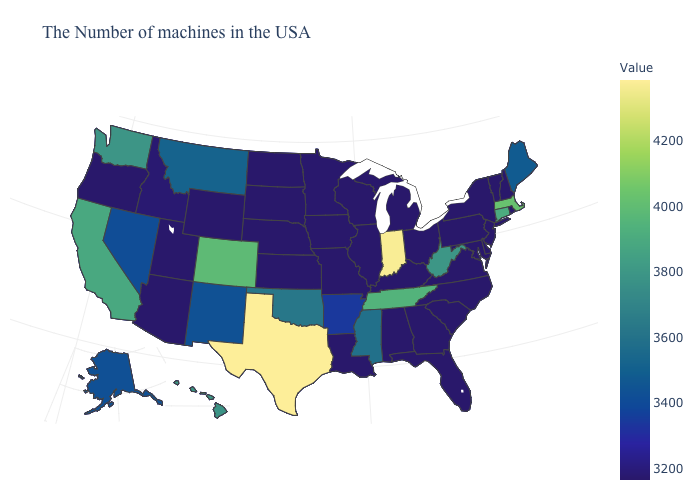Which states have the lowest value in the USA?
Keep it brief. Rhode Island, New Hampshire, Vermont, New York, New Jersey, Delaware, Maryland, Pennsylvania, Virginia, North Carolina, South Carolina, Ohio, Florida, Georgia, Michigan, Kentucky, Alabama, Wisconsin, Illinois, Louisiana, Missouri, Iowa, Kansas, Nebraska, South Dakota, North Dakota, Wyoming, Utah, Arizona, Oregon. Does the map have missing data?
Concise answer only. No. Does Arkansas have a higher value than Ohio?
Answer briefly. Yes. Among the states that border Maryland , does Pennsylvania have the lowest value?
Short answer required. Yes. Does Wyoming have the highest value in the USA?
Keep it brief. No. Does Minnesota have the lowest value in the MidWest?
Short answer required. No. 